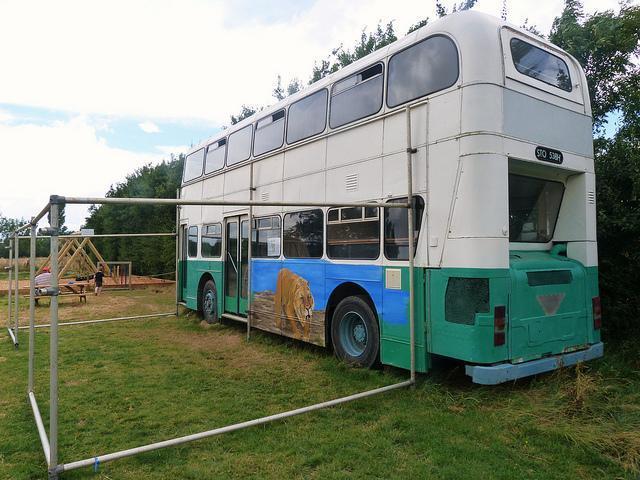Does the description: "The dining table is in front of the bus." accurately reflect the image?
Answer yes or no. Yes. 